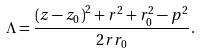Convert formula to latex. <formula><loc_0><loc_0><loc_500><loc_500>\Lambda = \frac { \left ( z - z _ { 0 } \right ) ^ { 2 } + r ^ { 2 } + r ^ { 2 } _ { 0 } - p ^ { 2 } } { 2 r r _ { 0 } } .</formula> 